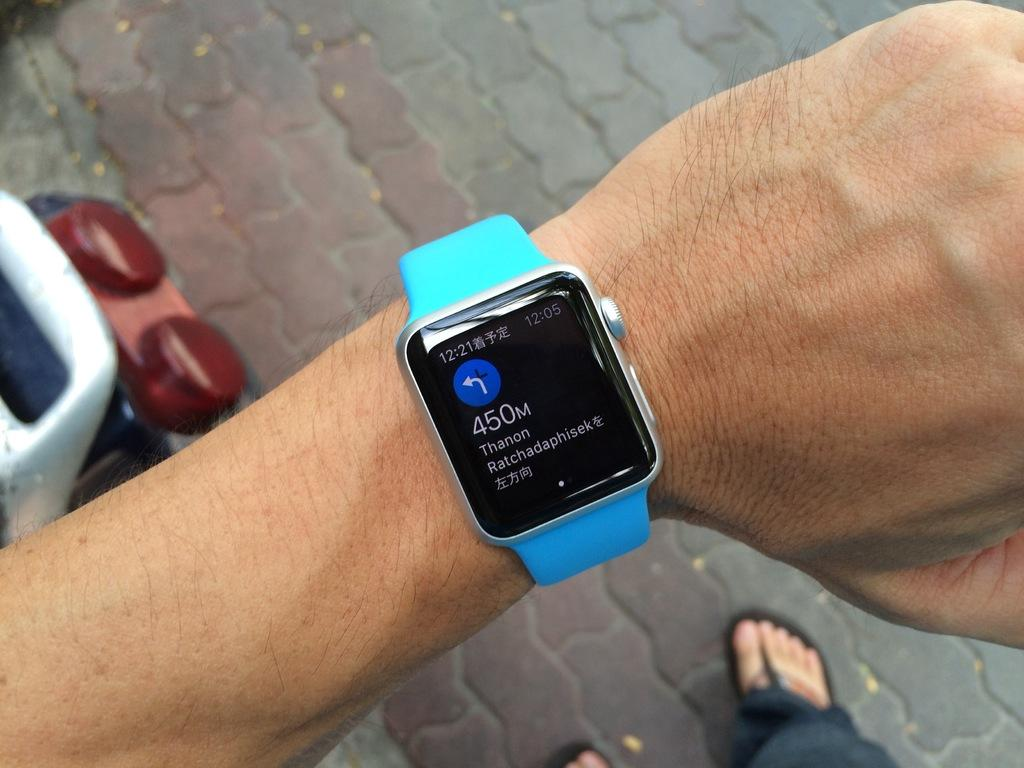What is present in the image? There is a person in the image. What can be seen on the person's hand? The person is wearing a watch on their hand. Can you describe the object below the person's hand? There is an object below the person's hand, but its details are not clear from the provided facts. How is the person positioned in the image? The person's legs are on the floor. What type of beef is being served in the image? There is no beef present in the image; it features a person wearing a watch with their legs on the floor. How does the judge in the image contribute to reducing pollution? There is no judge present in the image, and therefore no such contribution can be observed. 